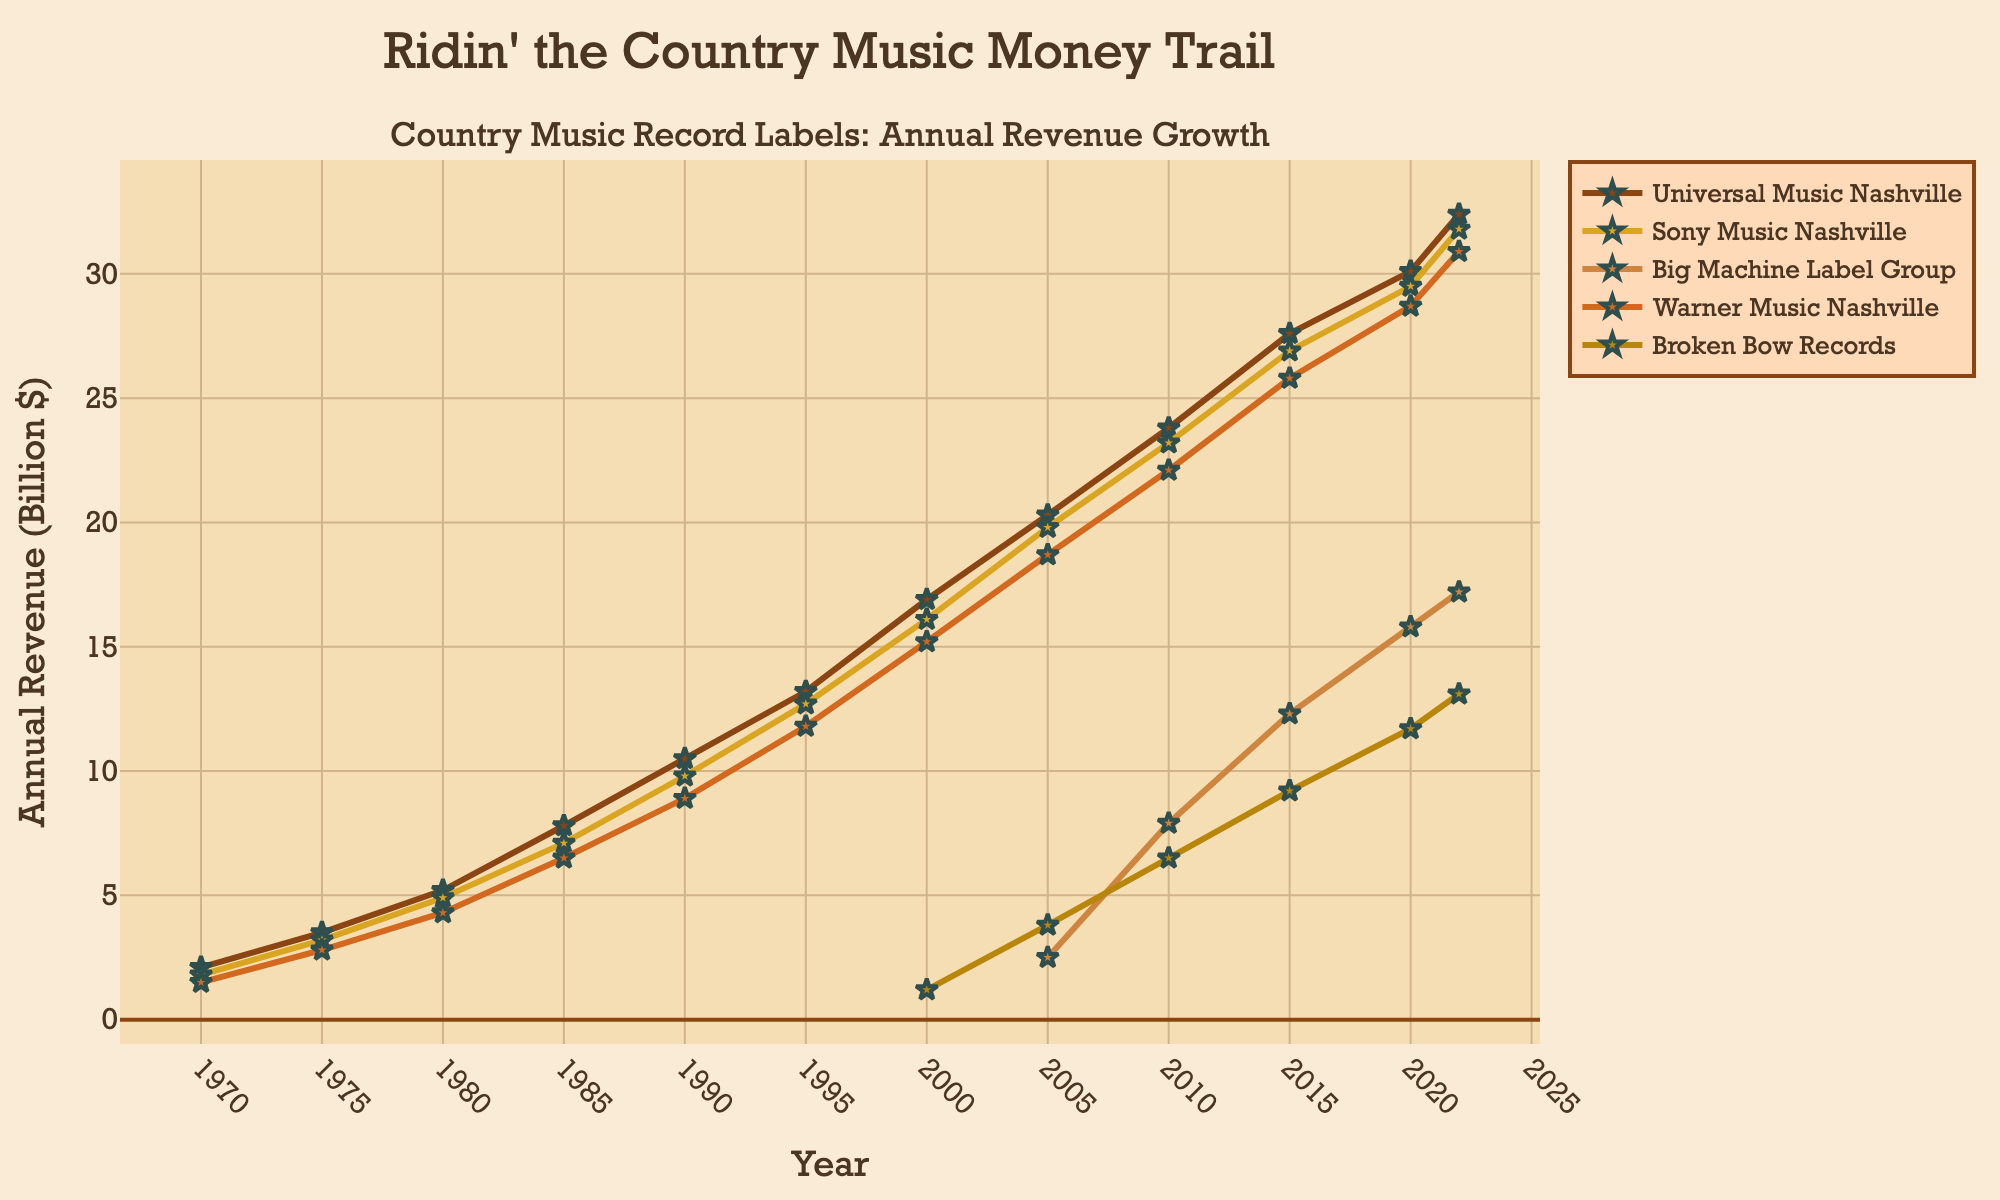What was the revenue of Universal Music Nashville in 1990? To find the revenue of Universal Music Nashville in 1990, locate the line corresponding to Universal Music Nashville and check its value at the year 1990.
Answer: 10.5 billion $ Which label had the highest revenue in 2022? Observing the lines at the year 2022, the label with the highest point on the revenue axis is Universal Music Nashville.
Answer: Universal Music Nashville By how much did Sony Music Nashville's revenue grow from 2000 to 2020? Calculate the difference in Sony Music Nashville's revenue between the years 2000 and 2020: 29.5 - 16.1 = 13.4 billion $.
Answer: 13.4 billion $ Which two labels had the closest revenues in 2010? In 2010, compare the distances between the revenues for each pair of labels. Sony Music Nashville and Warner Music Nashville have the closest values at 23.2 and 22.1 billion $, respectively.
Answer: Sony Music Nashville and Warner Music Nashville How many years after its introduction in the data did Broken Bow Records reach a revenue of over 10 billion $? Locate the first year Broken Bow Records appears (2000) and find the year it first surpasses 10 billion $ which is in 2020. The difference is 2020 - 2000 = 20 years.
Answer: 20 years Did Big Machine Label Group's revenue ever surpass Sony Music Nashville's revenue? Compare the line for Big Machine Label Group with the line for Sony Music Nashville across the years. Big Machine Label Group never surpasses Sony Music Nashville.
Answer: No What is the average revenue of Warner Music Nashville from 1970 to 2022? Sum the revenue values for Warner Music Nashville from all the years and divide by the number of years (12). (1.5 + 2.8 + 4.3 + 6.5 + 8.9 + 11.8 + 15.2 + 18.7 + 22.1 + 25.8 + 28.7 + 30.9) / 12 = 16.11 billion $.
Answer: 16.11 billion $ Which label showed the largest growth between 2005 and 2010? Calculate the revenue difference for each label between 2005 and 2010. Big Machine Label Group had the largest growth: 7.9 - 2.5 = 5.4 billion $.
Answer: Big Machine Label Group Was there any year when all five labels showed an increase in revenue compared to the previous year? Assess year-over-year changes for all five lines. In 2022, all listed labels show an increase in revenue compared to 2020.
Answer: Yes 